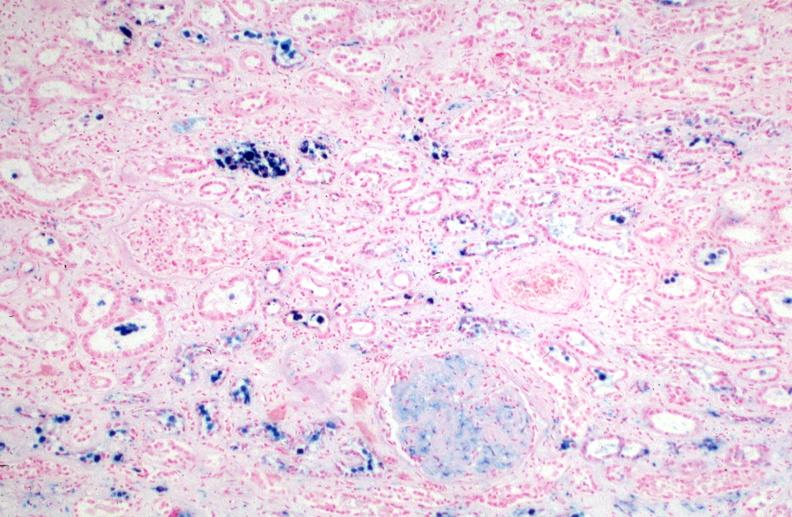how is hemosiderosis caused?
Answer the question using a single word or phrase. Numerous blood transfusions.prusian blue 